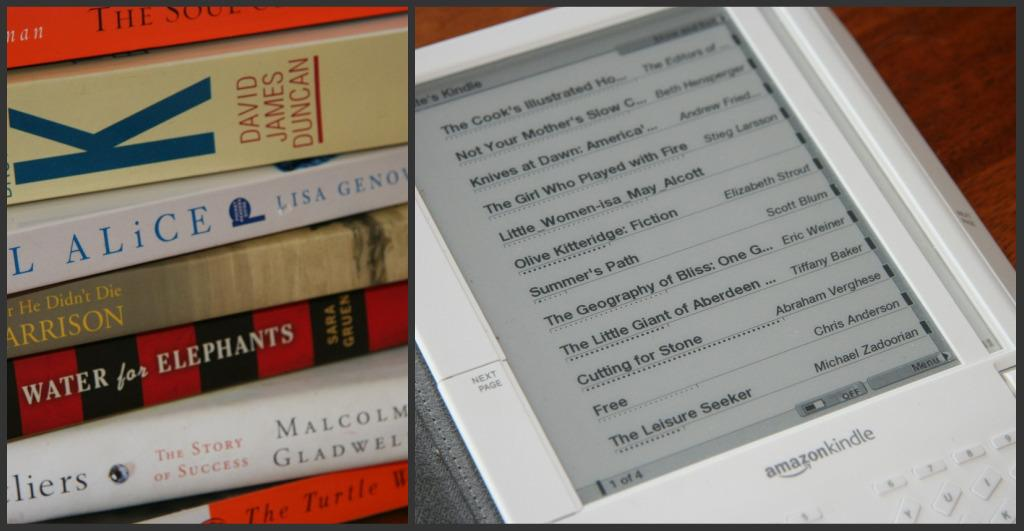<image>
Render a clear and concise summary of the photo. The split screen shows a stack of books on the left and a list of book titles on Amazon Kindle on the right. 